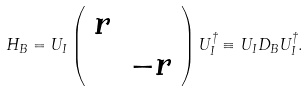Convert formula to latex. <formula><loc_0><loc_0><loc_500><loc_500>H _ { B } = U _ { I } \left ( \begin{array} { c c } r & \\ & - r \end{array} \right ) U _ { I } ^ { \dagger } \equiv U _ { I } D _ { B } U _ { I } ^ { \dagger } .</formula> 